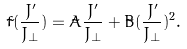<formula> <loc_0><loc_0><loc_500><loc_500>\tilde { f } ( \frac { J ^ { \prime } } { J _ { \bot } } ) = \tilde { A } \frac { J ^ { \prime } } { J _ { \bot } } + \tilde { B } ( \frac { J ^ { \prime } } { J _ { \bot } } ) ^ { 2 } .</formula> 